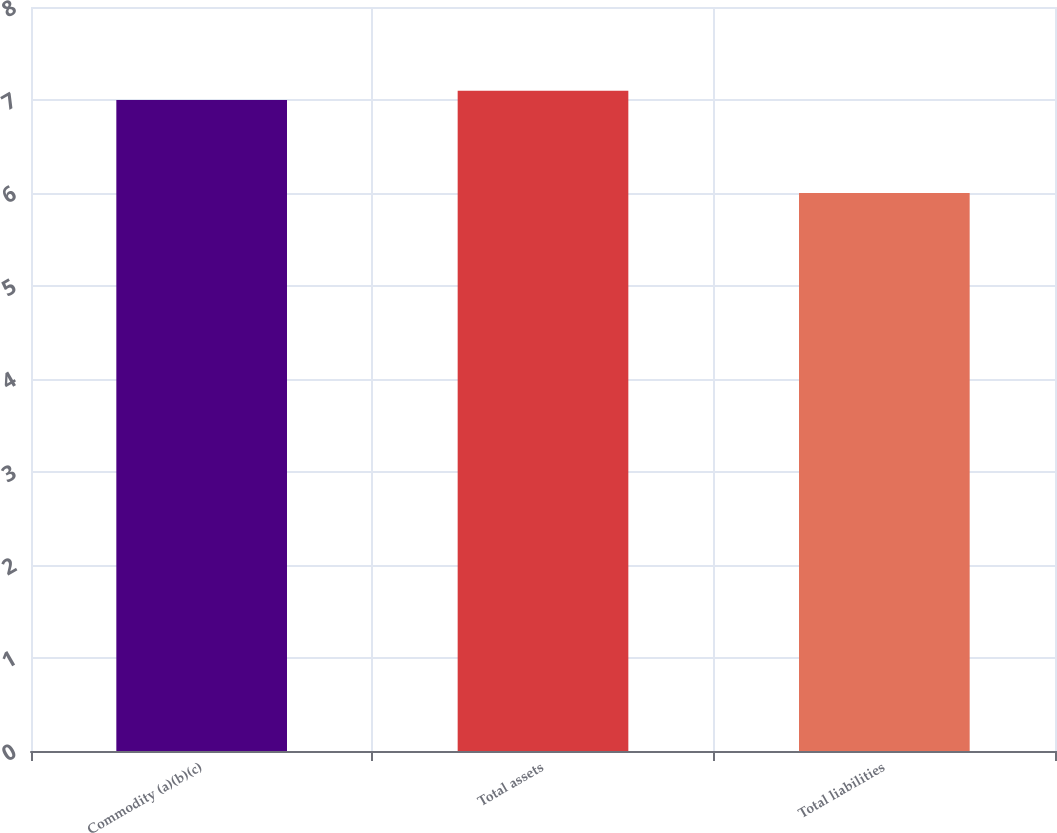<chart> <loc_0><loc_0><loc_500><loc_500><bar_chart><fcel>Commodity (a)(b)(c)<fcel>Total assets<fcel>Total liabilities<nl><fcel>7<fcel>7.1<fcel>6<nl></chart> 